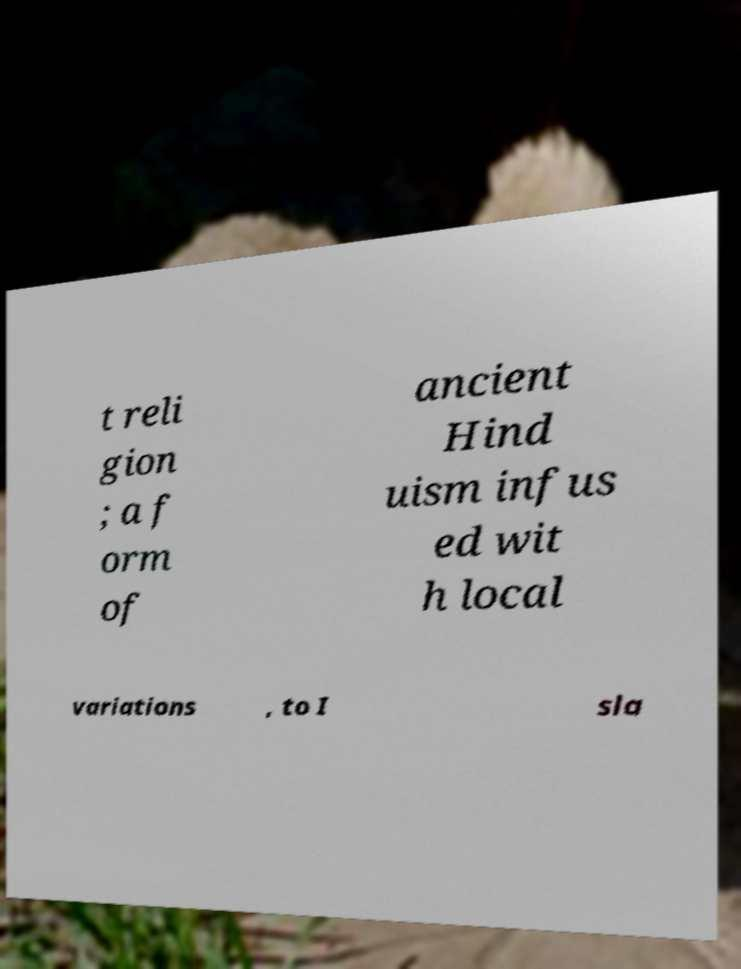I need the written content from this picture converted into text. Can you do that? t reli gion ; a f orm of ancient Hind uism infus ed wit h local variations , to I sla 